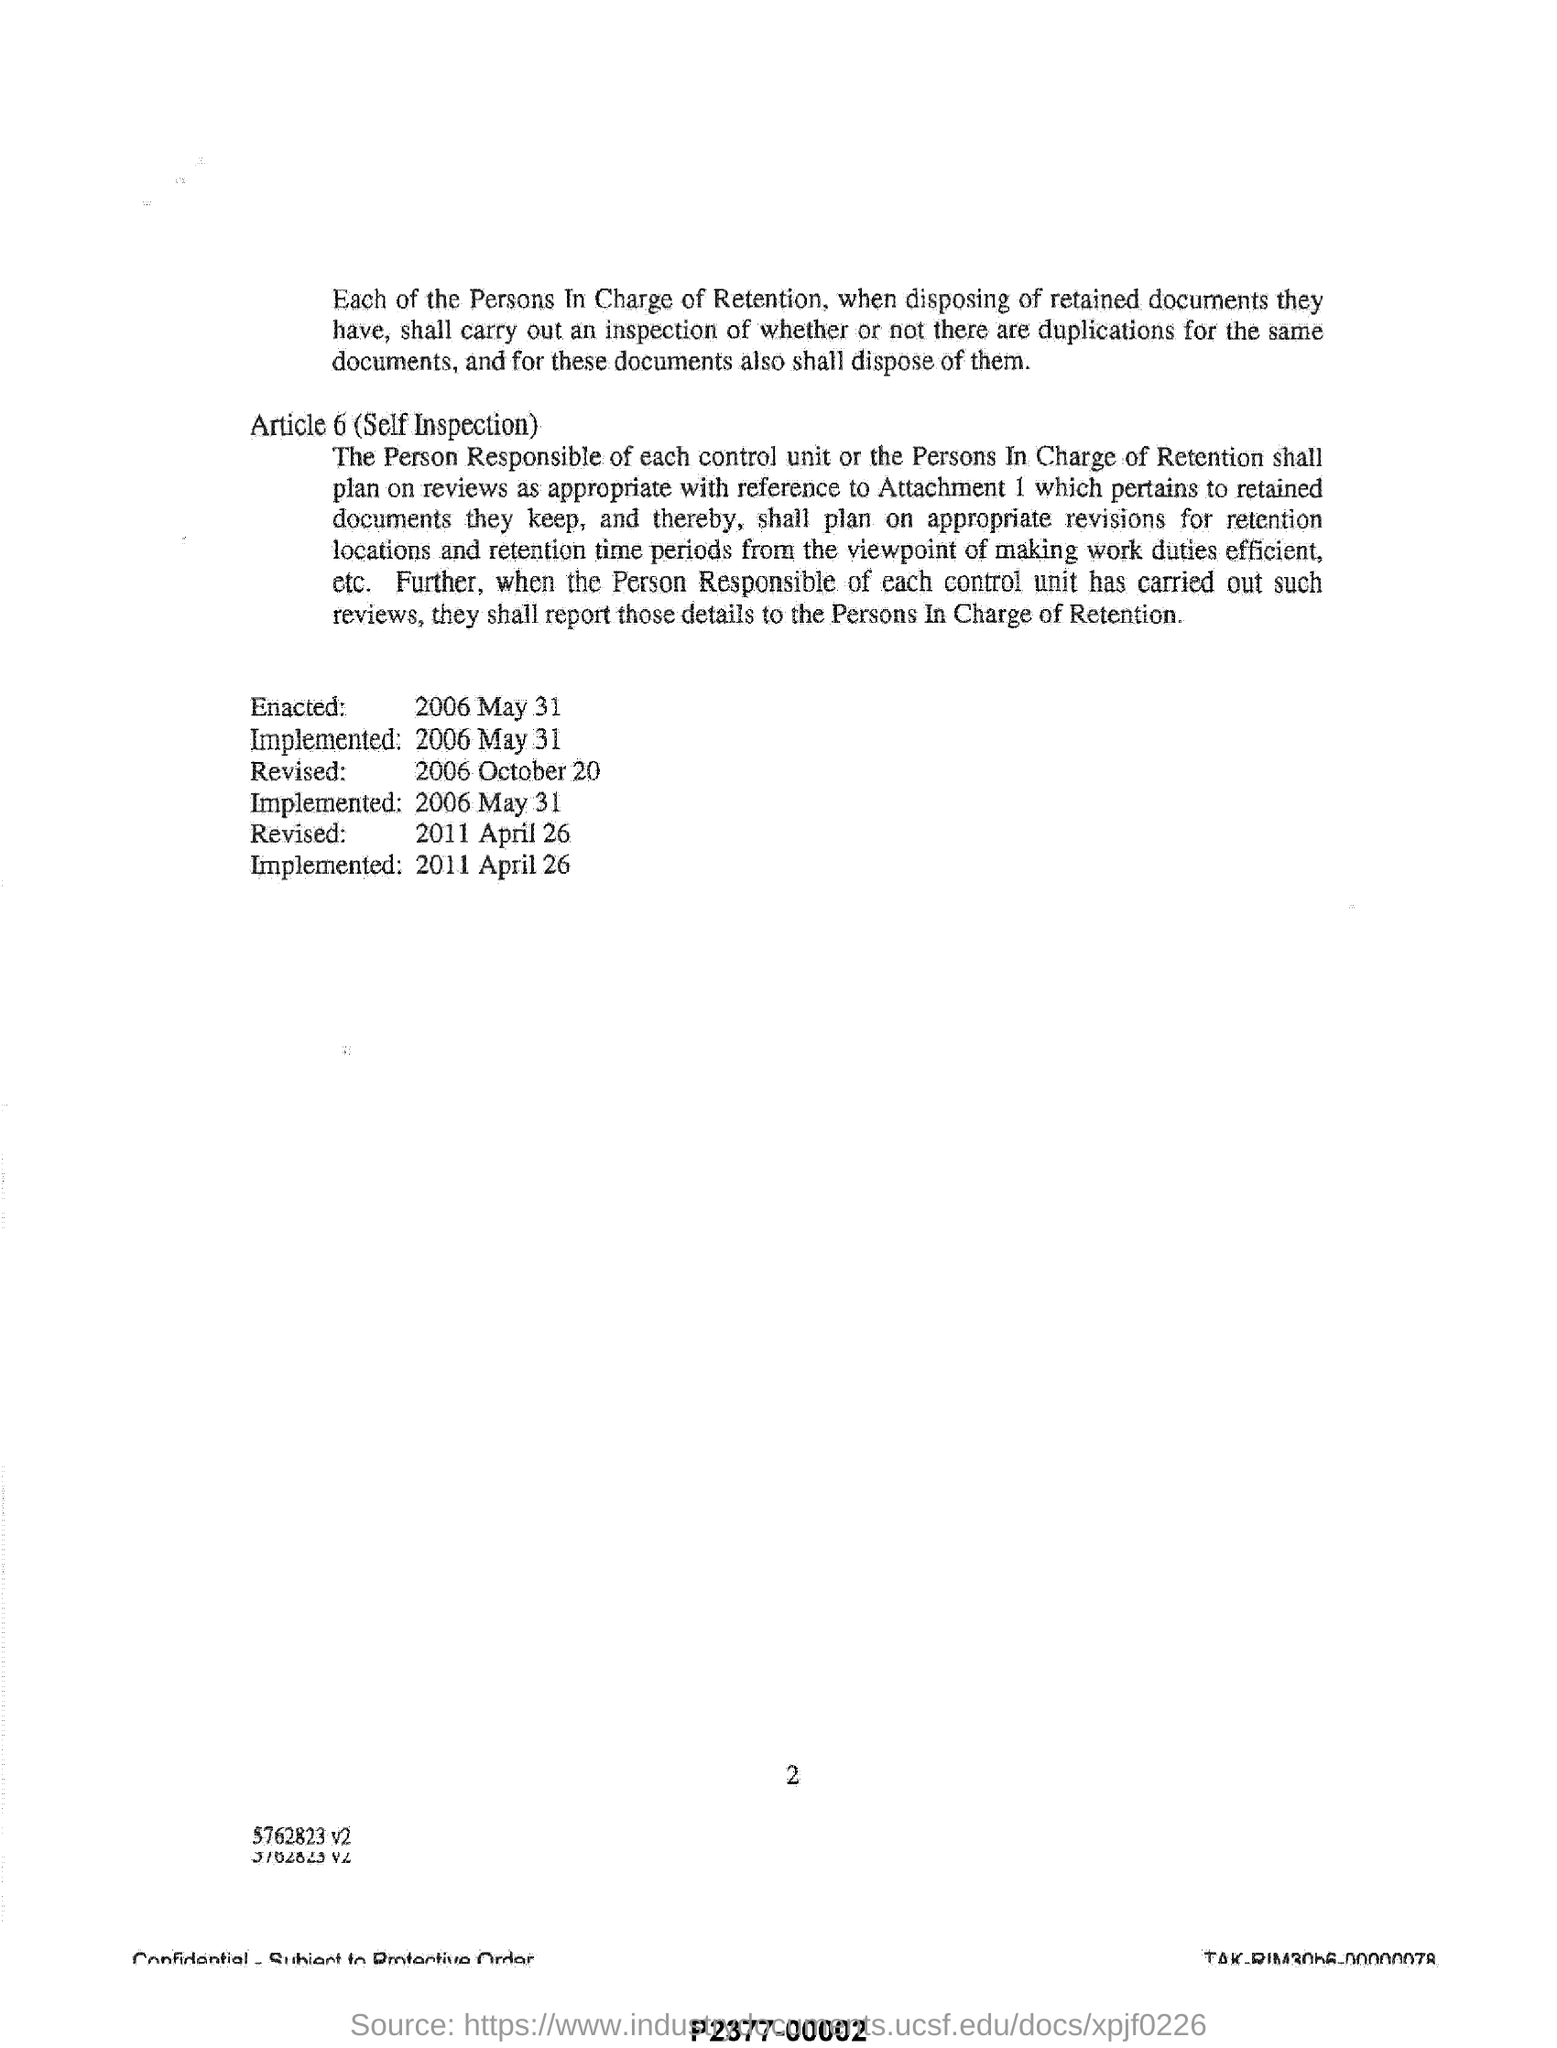Draw attention to some important aspects in this diagram. This document was enacted on May 31, 2006. I declare that the Article 6 is called Self Inspection. The second revision was made on April 26, 2011. 